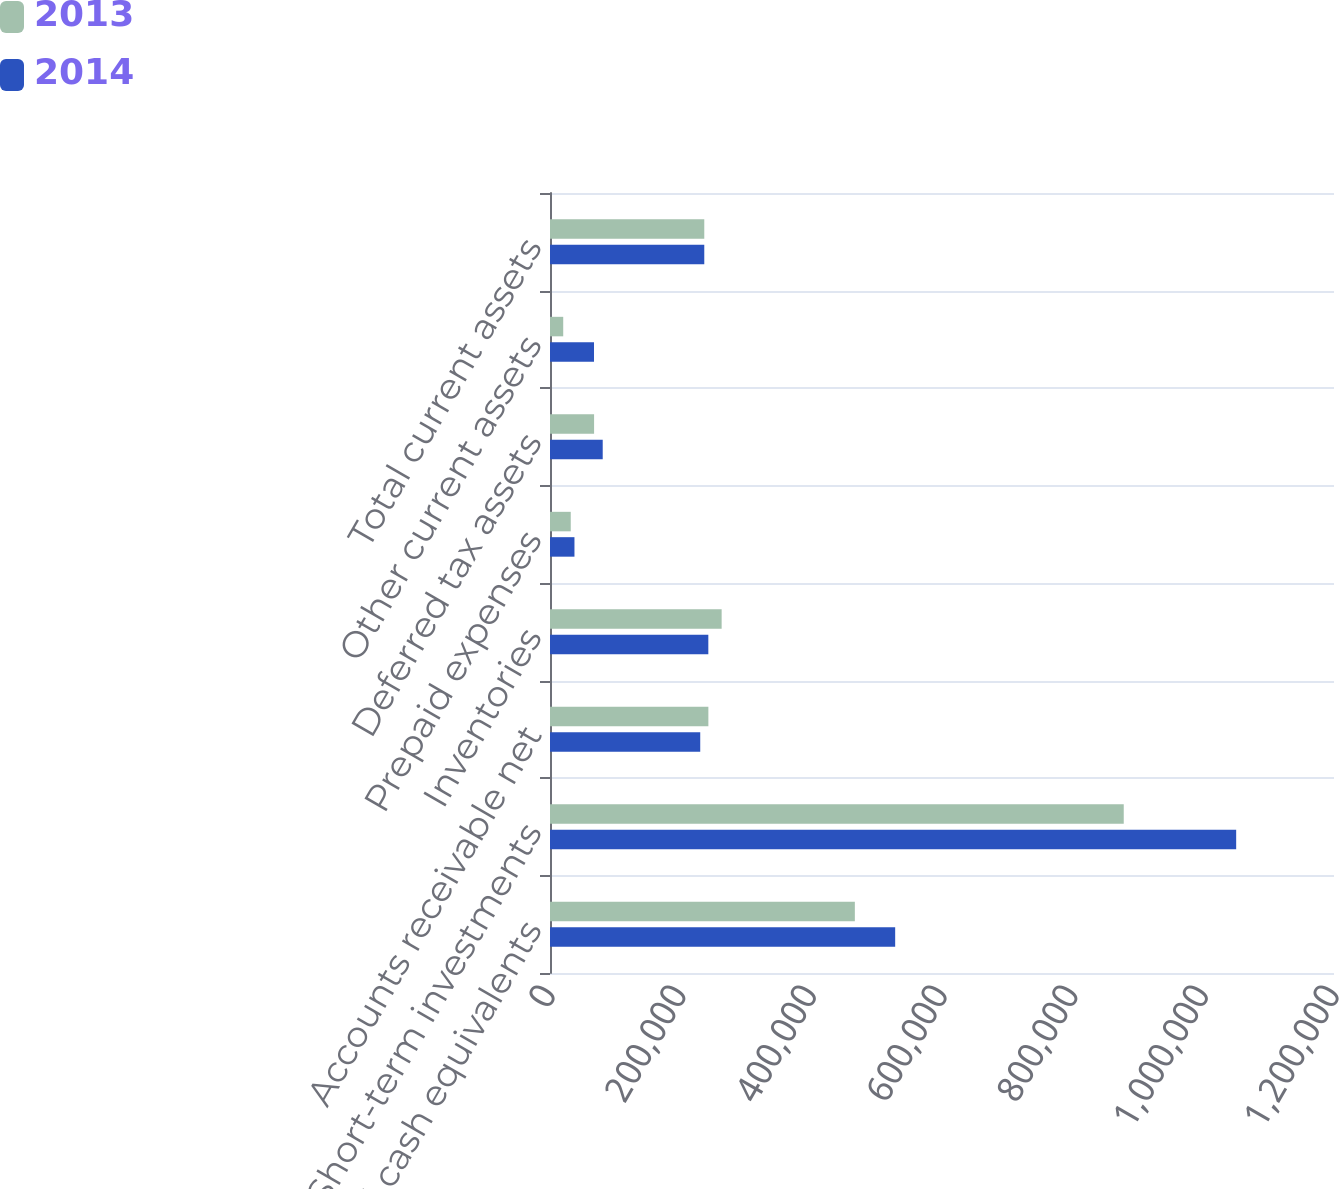<chart> <loc_0><loc_0><loc_500><loc_500><stacked_bar_chart><ecel><fcel>Cash and cash equivalents<fcel>Short-term investments<fcel>Accounts receivable net<fcel>Inventories<fcel>Prepaid expenses<fcel>Deferred tax assets<fcel>Other current assets<fcel>Total current assets<nl><fcel>2013<fcel>466603<fcel>878182<fcel>242405<fcel>262725<fcel>31756<fcel>67490<fcel>20238<fcel>236144<nl><fcel>2014<fcel>528334<fcel>1.05026e+06<fcel>229955<fcel>242334<fcel>37439<fcel>80687<fcel>67358<fcel>236144<nl></chart> 